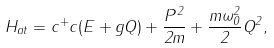Convert formula to latex. <formula><loc_0><loc_0><loc_500><loc_500>H _ { a t } = c ^ { + } c ( E + g Q ) + \frac { P ^ { 2 } } { 2 m } + \frac { m \omega _ { 0 } ^ { 2 } } { 2 } Q ^ { 2 } ,</formula> 